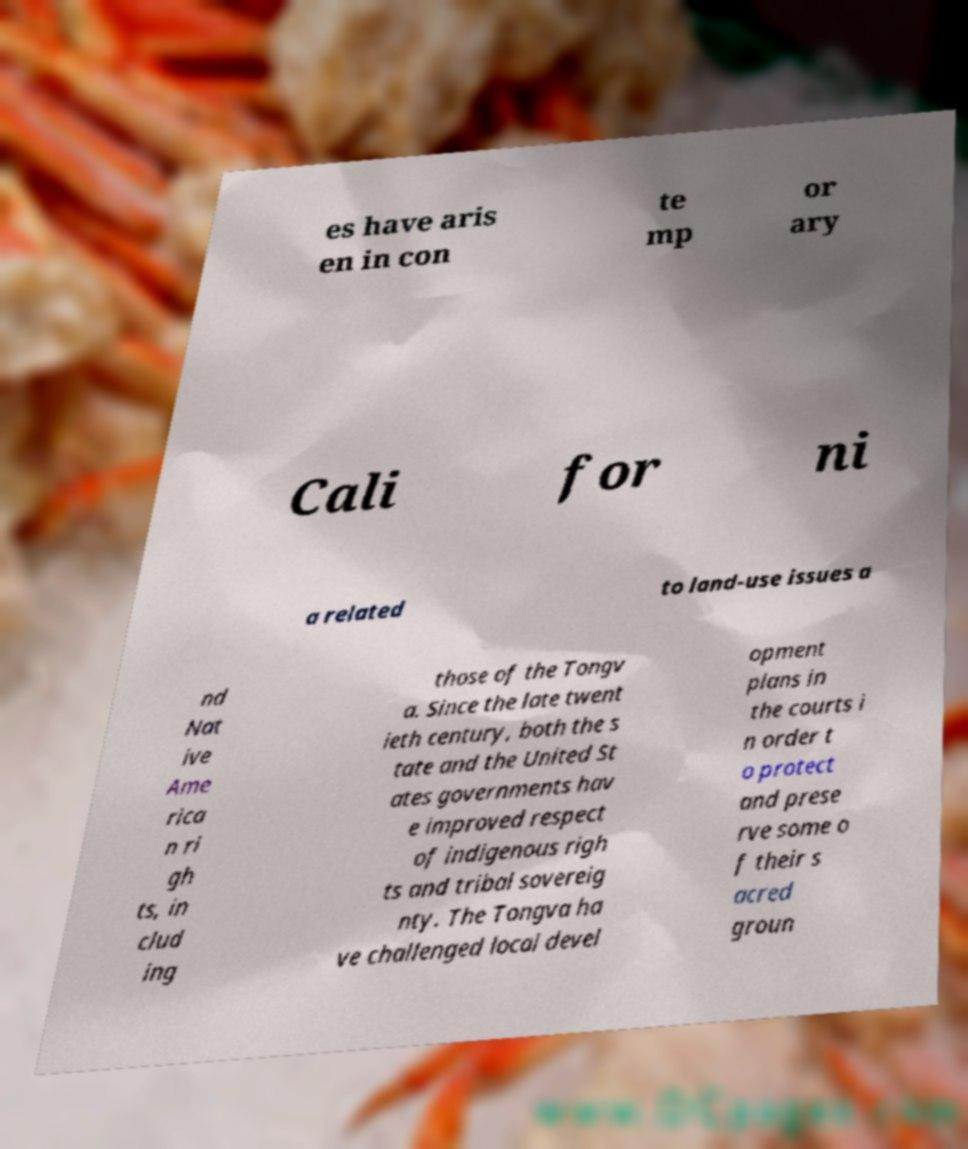Please identify and transcribe the text found in this image. es have aris en in con te mp or ary Cali for ni a related to land-use issues a nd Nat ive Ame rica n ri gh ts, in clud ing those of the Tongv a. Since the late twent ieth century, both the s tate and the United St ates governments hav e improved respect of indigenous righ ts and tribal sovereig nty. The Tongva ha ve challenged local devel opment plans in the courts i n order t o protect and prese rve some o f their s acred groun 